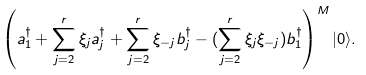Convert formula to latex. <formula><loc_0><loc_0><loc_500><loc_500>\left ( a _ { 1 } ^ { \dagger } + \sum _ { j = 2 } ^ { r } \xi _ { j } a _ { j } ^ { \dagger } + \sum _ { j = 2 } ^ { r } \xi _ { - j } b _ { j } ^ { \dagger } - ( \sum _ { j = 2 } ^ { r } \xi _ { j } \xi _ { - j } ) b _ { 1 } ^ { \dagger } \right ) ^ { M } | 0 \rangle .</formula> 